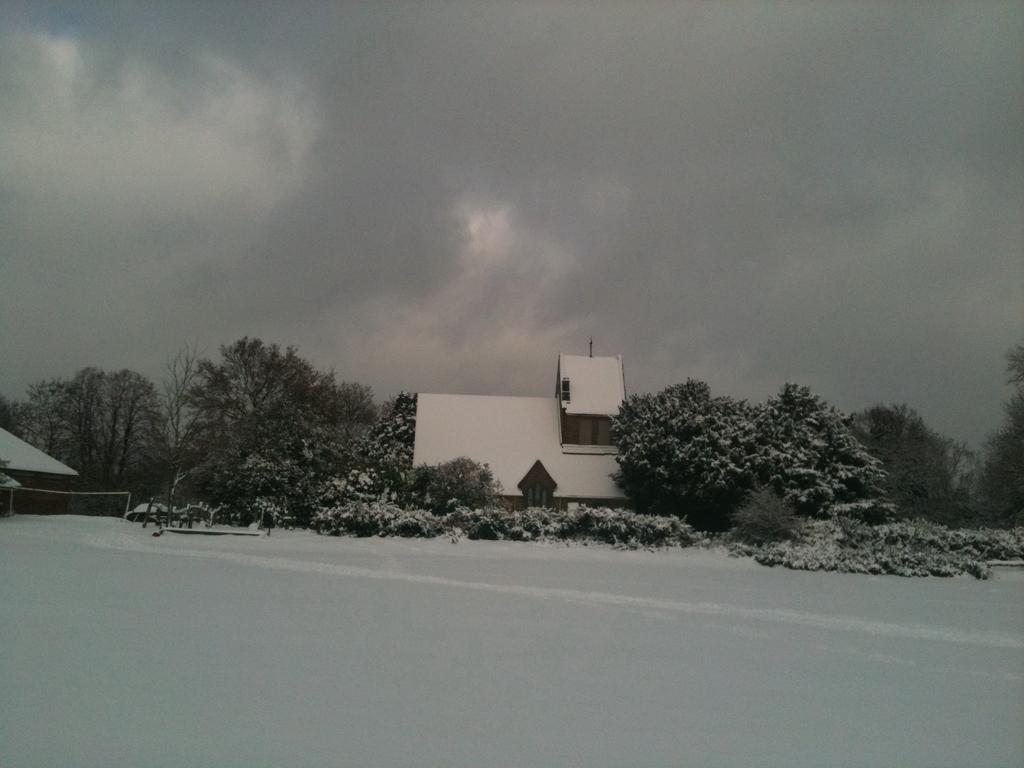What is the color scheme of the image? The image is black and white. What is the main subject of the image? There is a building in the image. What type of vegetation is present on either side of the building? There are trees on either side of the building. What is visible above the building? The sky is visible above the building. What type of ring is being worn by the tree on the left side of the building? There is no ring present in the image, as it features a building with trees on either side and a black and white color scheme. 